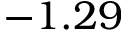<formula> <loc_0><loc_0><loc_500><loc_500>- 1 . 2 9</formula> 